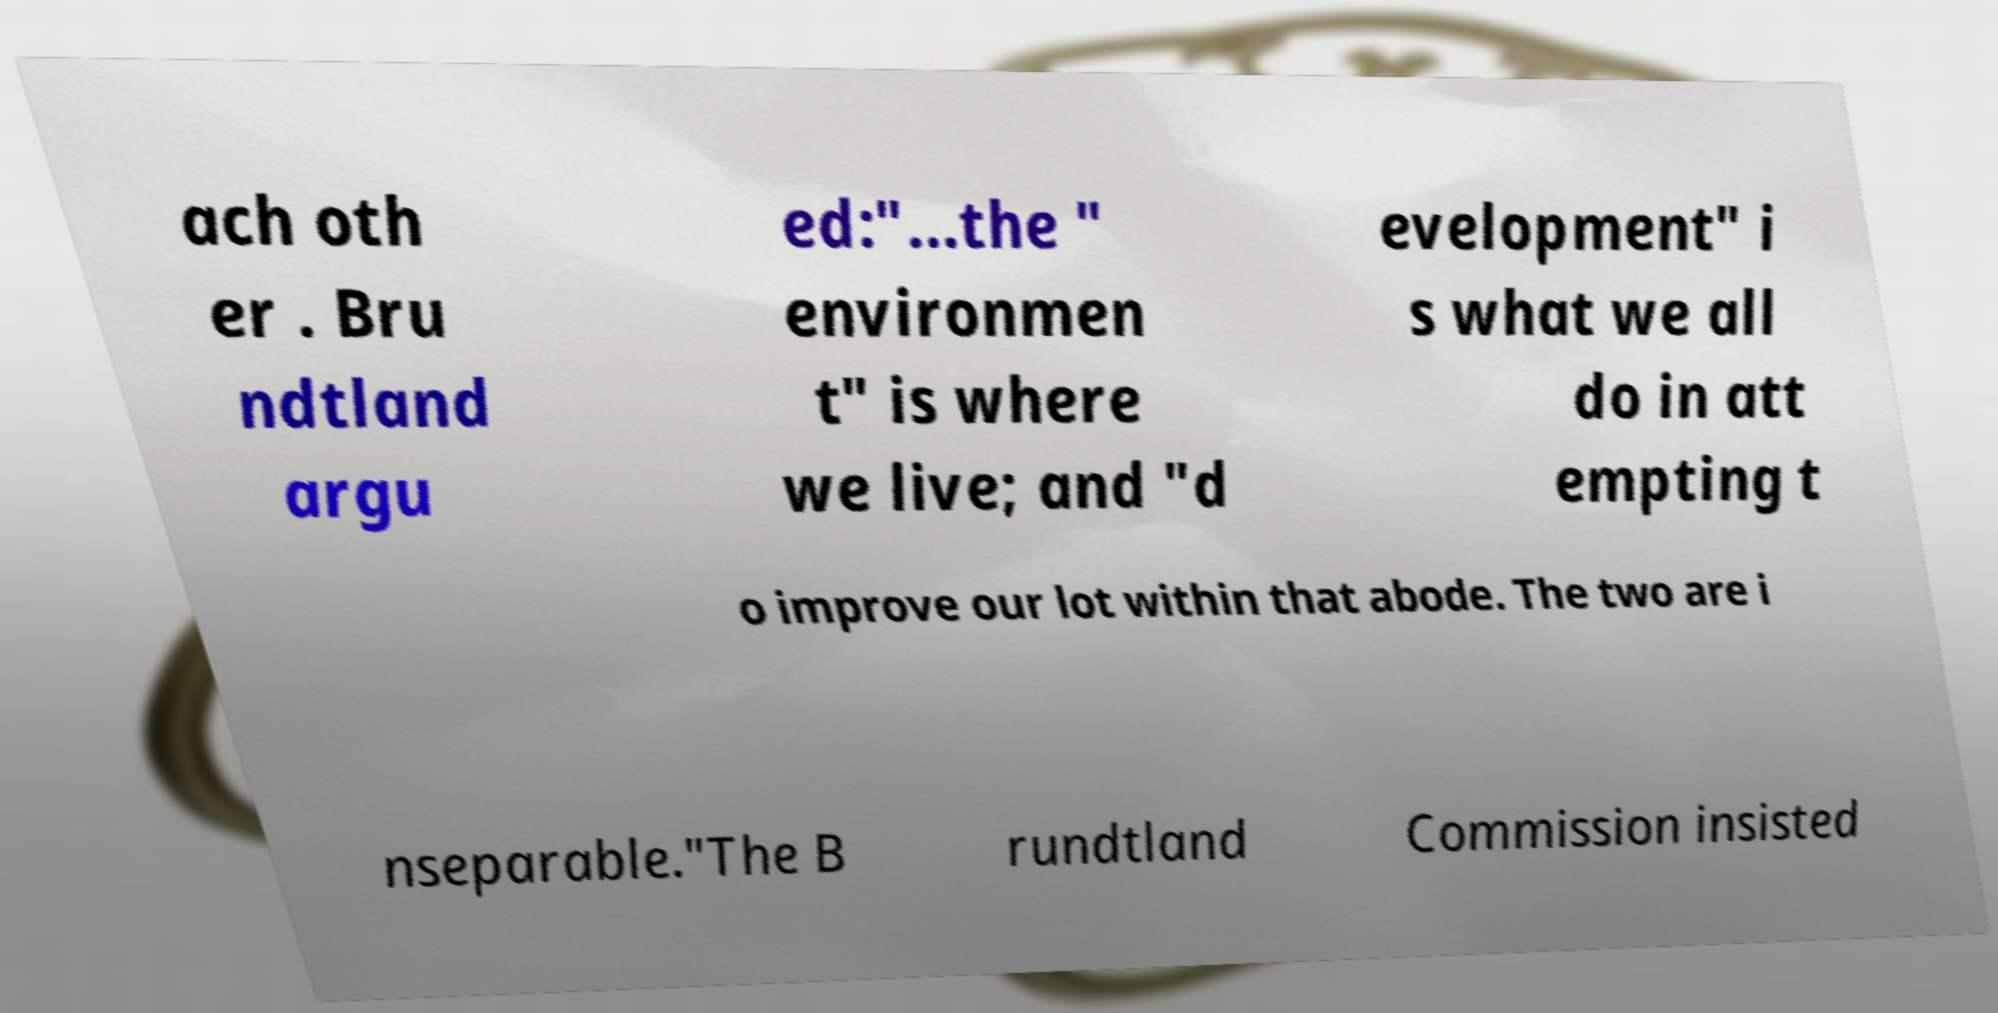Please identify and transcribe the text found in this image. ach oth er . Bru ndtland argu ed:"...the " environmen t" is where we live; and "d evelopment" i s what we all do in att empting t o improve our lot within that abode. The two are i nseparable."The B rundtland Commission insisted 